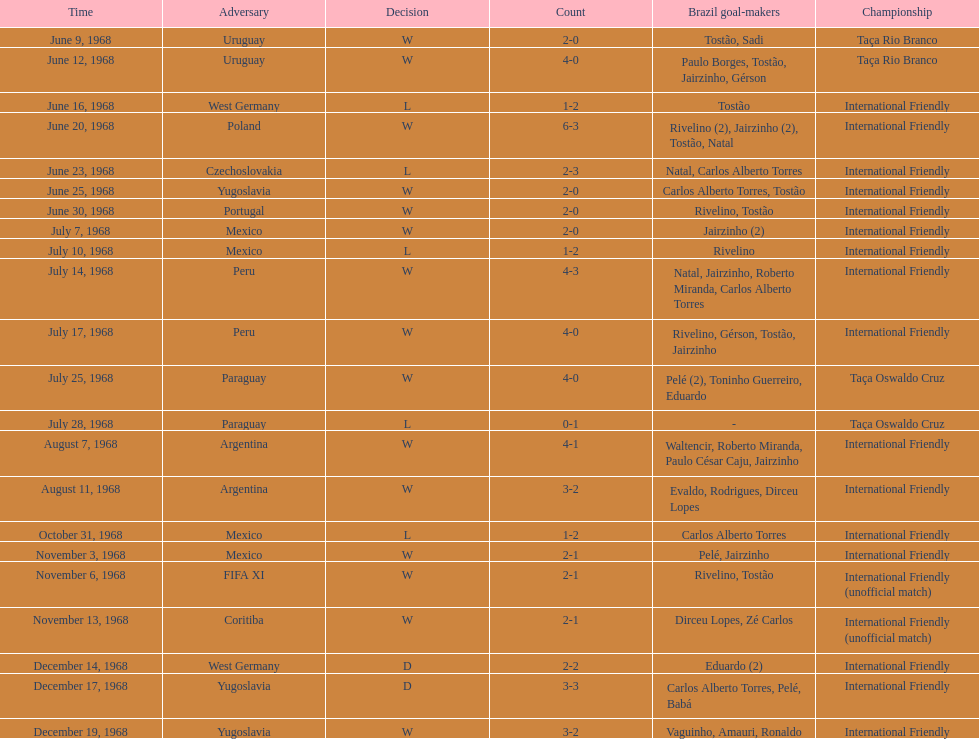What is the top score ever scored by the brazil national team? 6. 